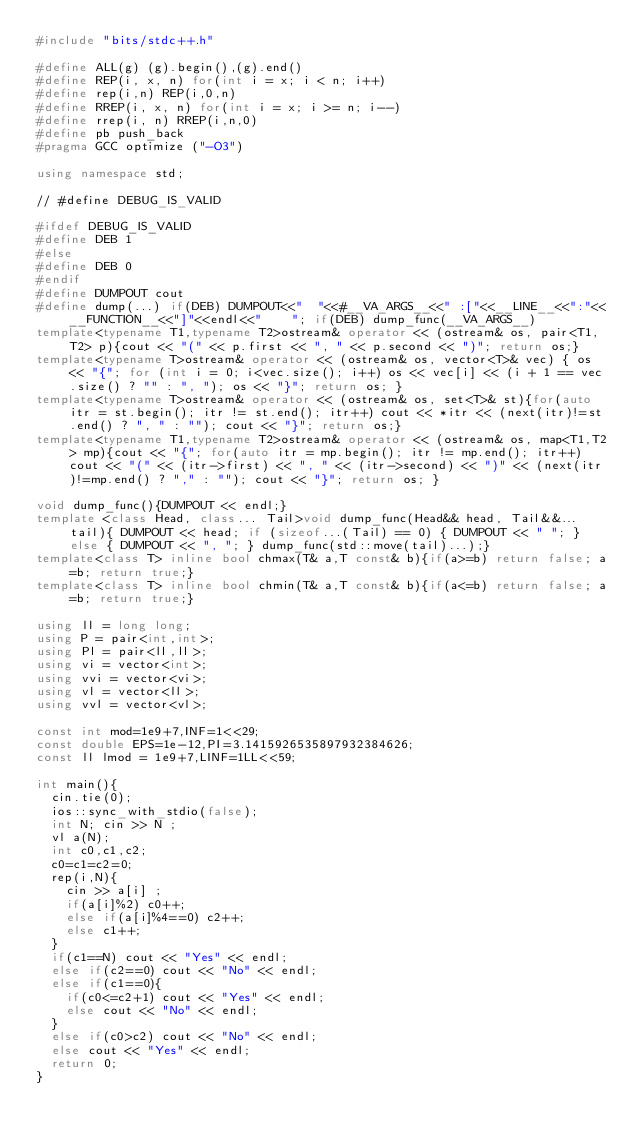<code> <loc_0><loc_0><loc_500><loc_500><_C++_>#include "bits/stdc++.h"

#define ALL(g) (g).begin(),(g).end()
#define REP(i, x, n) for(int i = x; i < n; i++)
#define rep(i,n) REP(i,0,n)
#define RREP(i, x, n) for(int i = x; i >= n; i--)
#define rrep(i, n) RREP(i,n,0)
#define pb push_back
#pragma GCC optimize ("-O3")

using namespace std;

// #define DEBUG_IS_VALID

#ifdef DEBUG_IS_VALID
#define DEB 1 
#else
#define DEB 0
#endif
#define DUMPOUT cout
#define dump(...) if(DEB) DUMPOUT<<"  "<<#__VA_ARGS__<<" :["<<__LINE__<<":"<<__FUNCTION__<<"]"<<endl<<"    "; if(DEB) dump_func(__VA_ARGS__)
template<typename T1,typename T2>ostream& operator << (ostream& os, pair<T1,T2> p){cout << "(" << p.first << ", " << p.second << ")"; return os;}
template<typename T>ostream& operator << (ostream& os, vector<T>& vec) { os << "{"; for (int i = 0; i<vec.size(); i++) os << vec[i] << (i + 1 == vec.size() ? "" : ", "); os << "}"; return os; }
template<typename T>ostream& operator << (ostream& os, set<T>& st){for(auto itr = st.begin(); itr != st.end(); itr++) cout << *itr << (next(itr)!=st.end() ? ", " : ""); cout << "}"; return os;}
template<typename T1,typename T2>ostream& operator << (ostream& os, map<T1,T2> mp){cout << "{"; for(auto itr = mp.begin(); itr != mp.end(); itr++) cout << "(" << (itr->first) << ", " << (itr->second) << ")" << (next(itr)!=mp.end() ? "," : ""); cout << "}"; return os; }

void dump_func(){DUMPOUT << endl;}
template <class Head, class... Tail>void dump_func(Head&& head, Tail&&... tail){ DUMPOUT << head; if (sizeof...(Tail) == 0) { DUMPOUT << " "; } else { DUMPOUT << ", "; } dump_func(std::move(tail)...);}
template<class T> inline bool chmax(T& a,T const& b){if(a>=b) return false; a=b; return true;}
template<class T> inline bool chmin(T& a,T const& b){if(a<=b) return false; a=b; return true;}

using ll = long long;
using P = pair<int,int>;
using Pl = pair<ll,ll>;
using vi = vector<int>;
using vvi = vector<vi>;
using vl = vector<ll>;
using vvl = vector<vl>;

const int mod=1e9+7,INF=1<<29;
const double EPS=1e-12,PI=3.1415926535897932384626;
const ll lmod = 1e9+7,LINF=1LL<<59; 

int main(){
  cin.tie(0);
  ios::sync_with_stdio(false);
  int N; cin >> N ;
  vl a(N);
  int c0,c1,c2;
  c0=c1=c2=0;
  rep(i,N){
    cin >> a[i] ;
    if(a[i]%2) c0++;
    else if(a[i]%4==0) c2++;
    else c1++;
  }
  if(c1==N) cout << "Yes" << endl;
  else if(c2==0) cout << "No" << endl;
  else if(c1==0){
    if(c0<=c2+1) cout << "Yes" << endl;
    else cout << "No" << endl;
  }
  else if(c0>c2) cout << "No" << endl;
  else cout << "Yes" << endl;
  return 0;
}
</code> 